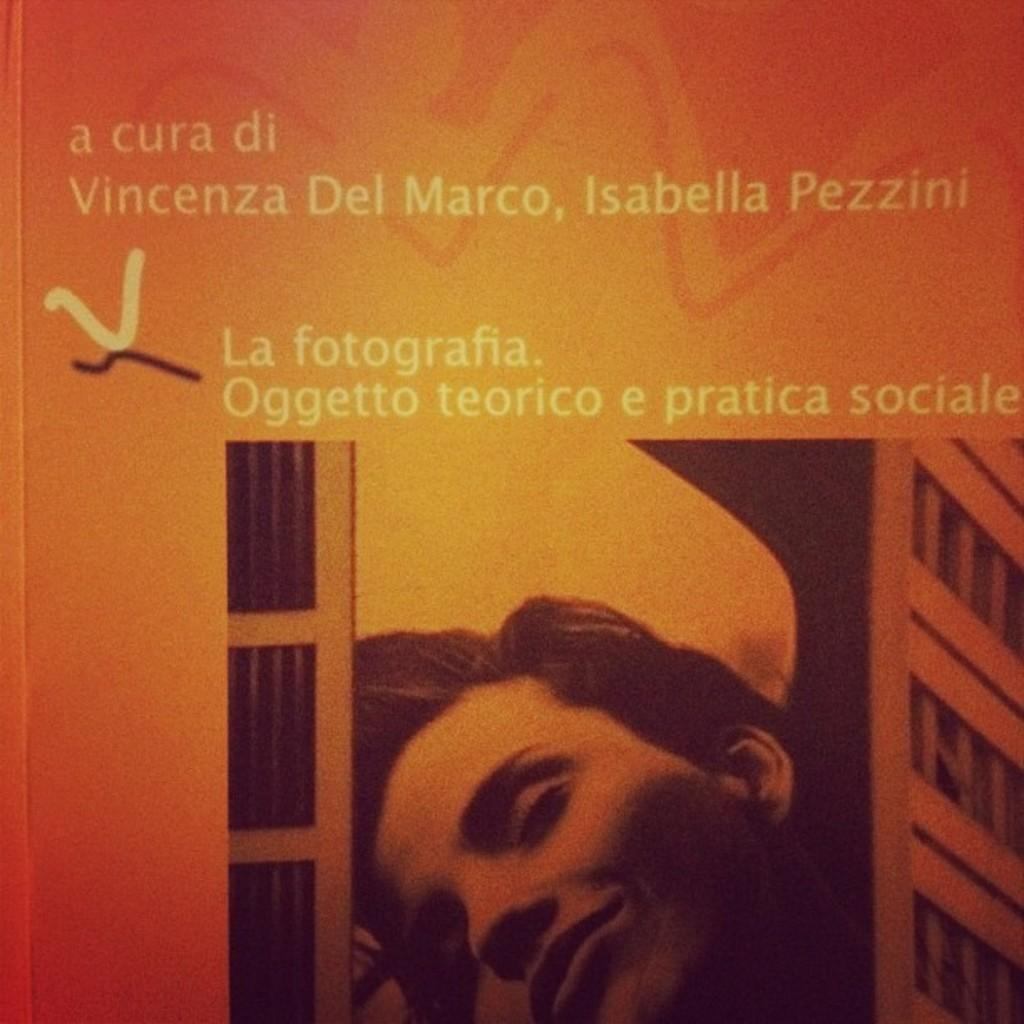What type of visual is the image? The image is a book cover or a poster. Where is the person's face located in the image? The person's face is at the bottom of the image. What can be seen on the right side of the image? There is a building on the right side of the image. What is present at the top of the image? There is text at the top of the image. What type of roof is visible on the building in the image? There is no roof visible on the building in the image; only the side of the building is shown. What part of the city is depicted in the image? The image does not specify a particular location or part of the city; it only shows a building and a person's face. 